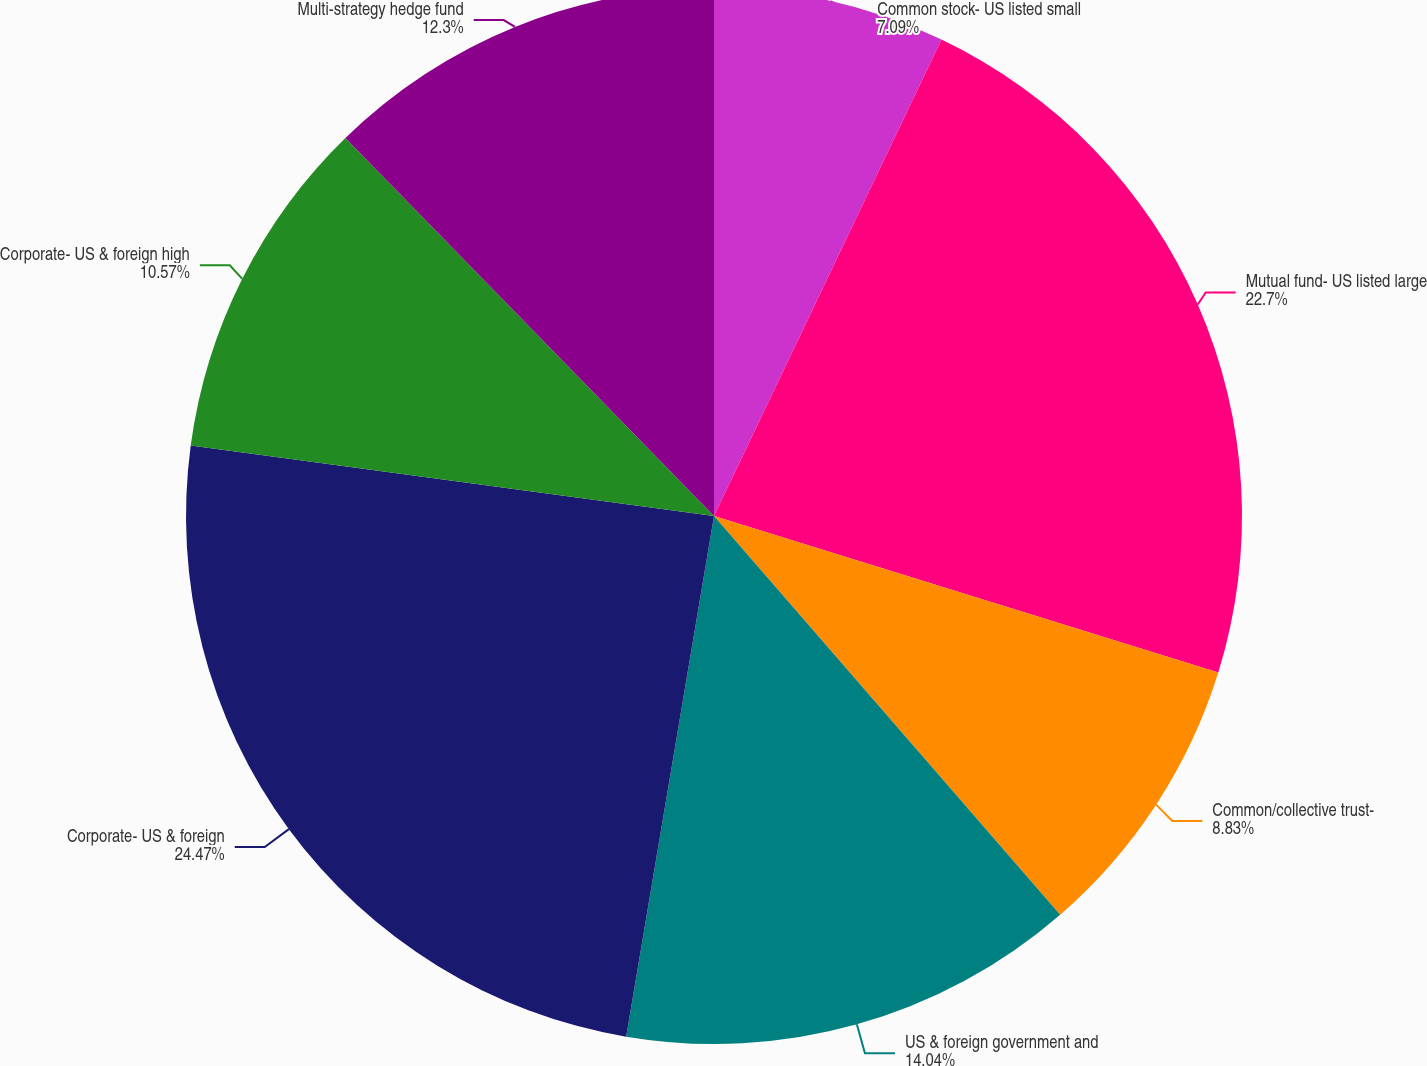<chart> <loc_0><loc_0><loc_500><loc_500><pie_chart><fcel>Common stock- US listed small<fcel>Mutual fund- US listed large<fcel>Common/collective trust-<fcel>US & foreign government and<fcel>Corporate- US & foreign<fcel>Corporate- US & foreign high<fcel>Multi-strategy hedge fund<nl><fcel>7.09%<fcel>22.7%<fcel>8.83%<fcel>14.04%<fcel>24.47%<fcel>10.57%<fcel>12.3%<nl></chart> 